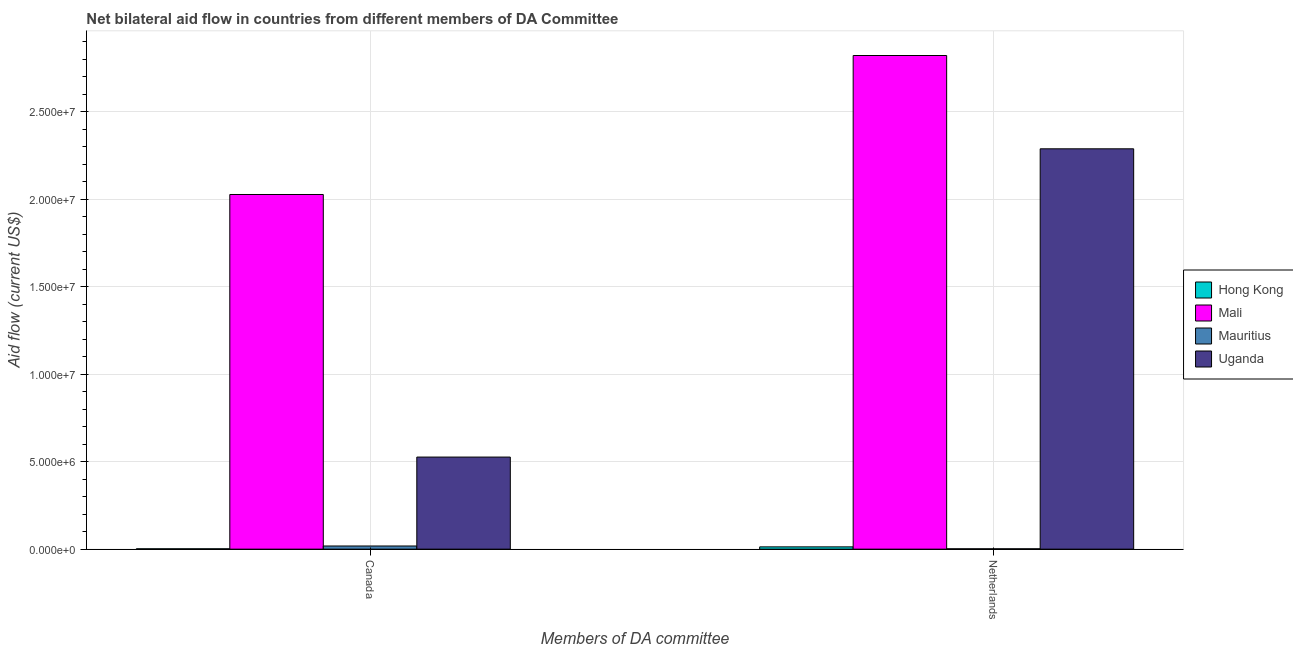Are the number of bars per tick equal to the number of legend labels?
Keep it short and to the point. Yes. How many bars are there on the 1st tick from the left?
Your answer should be very brief. 4. How many bars are there on the 1st tick from the right?
Make the answer very short. 4. What is the label of the 1st group of bars from the left?
Give a very brief answer. Canada. What is the amount of aid given by canada in Mali?
Your answer should be very brief. 2.03e+07. Across all countries, what is the maximum amount of aid given by canada?
Your answer should be very brief. 2.03e+07. Across all countries, what is the minimum amount of aid given by canada?
Provide a succinct answer. 2.00e+04. In which country was the amount of aid given by netherlands maximum?
Offer a terse response. Mali. In which country was the amount of aid given by netherlands minimum?
Your answer should be very brief. Mauritius. What is the total amount of aid given by netherlands in the graph?
Your answer should be very brief. 5.12e+07. What is the difference between the amount of aid given by canada in Mali and that in Mauritius?
Provide a short and direct response. 2.01e+07. What is the difference between the amount of aid given by canada in Hong Kong and the amount of aid given by netherlands in Mauritius?
Make the answer very short. 0. What is the average amount of aid given by canada per country?
Offer a terse response. 6.43e+06. What is the difference between the amount of aid given by netherlands and amount of aid given by canada in Mauritius?
Offer a very short reply. -1.60e+05. In how many countries, is the amount of aid given by canada greater than 17000000 US$?
Offer a terse response. 1. What is the ratio of the amount of aid given by canada in Mauritius to that in Mali?
Your answer should be very brief. 0.01. Is the amount of aid given by netherlands in Mali less than that in Uganda?
Provide a succinct answer. No. In how many countries, is the amount of aid given by canada greater than the average amount of aid given by canada taken over all countries?
Keep it short and to the point. 1. What does the 3rd bar from the left in Canada represents?
Your response must be concise. Mauritius. What does the 2nd bar from the right in Canada represents?
Offer a terse response. Mauritius. Are all the bars in the graph horizontal?
Your response must be concise. No. How many countries are there in the graph?
Give a very brief answer. 4. What is the difference between two consecutive major ticks on the Y-axis?
Your response must be concise. 5.00e+06. Are the values on the major ticks of Y-axis written in scientific E-notation?
Your answer should be compact. Yes. Does the graph contain any zero values?
Give a very brief answer. No. Where does the legend appear in the graph?
Provide a succinct answer. Center right. How many legend labels are there?
Make the answer very short. 4. How are the legend labels stacked?
Provide a short and direct response. Vertical. What is the title of the graph?
Keep it short and to the point. Net bilateral aid flow in countries from different members of DA Committee. What is the label or title of the X-axis?
Your response must be concise. Members of DA committee. What is the Aid flow (current US$) of Hong Kong in Canada?
Offer a very short reply. 2.00e+04. What is the Aid flow (current US$) of Mali in Canada?
Keep it short and to the point. 2.03e+07. What is the Aid flow (current US$) of Uganda in Canada?
Make the answer very short. 5.26e+06. What is the Aid flow (current US$) of Hong Kong in Netherlands?
Offer a very short reply. 1.30e+05. What is the Aid flow (current US$) in Mali in Netherlands?
Ensure brevity in your answer.  2.82e+07. What is the Aid flow (current US$) of Mauritius in Netherlands?
Give a very brief answer. 2.00e+04. What is the Aid flow (current US$) in Uganda in Netherlands?
Your answer should be very brief. 2.29e+07. Across all Members of DA committee, what is the maximum Aid flow (current US$) of Mali?
Provide a succinct answer. 2.82e+07. Across all Members of DA committee, what is the maximum Aid flow (current US$) of Mauritius?
Offer a terse response. 1.80e+05. Across all Members of DA committee, what is the maximum Aid flow (current US$) of Uganda?
Provide a short and direct response. 2.29e+07. Across all Members of DA committee, what is the minimum Aid flow (current US$) in Hong Kong?
Offer a very short reply. 2.00e+04. Across all Members of DA committee, what is the minimum Aid flow (current US$) of Mali?
Offer a terse response. 2.03e+07. Across all Members of DA committee, what is the minimum Aid flow (current US$) of Uganda?
Provide a short and direct response. 5.26e+06. What is the total Aid flow (current US$) of Mali in the graph?
Provide a succinct answer. 4.85e+07. What is the total Aid flow (current US$) of Uganda in the graph?
Provide a succinct answer. 2.81e+07. What is the difference between the Aid flow (current US$) in Mali in Canada and that in Netherlands?
Offer a terse response. -7.94e+06. What is the difference between the Aid flow (current US$) of Mauritius in Canada and that in Netherlands?
Make the answer very short. 1.60e+05. What is the difference between the Aid flow (current US$) of Uganda in Canada and that in Netherlands?
Make the answer very short. -1.76e+07. What is the difference between the Aid flow (current US$) of Hong Kong in Canada and the Aid flow (current US$) of Mali in Netherlands?
Offer a terse response. -2.82e+07. What is the difference between the Aid flow (current US$) of Hong Kong in Canada and the Aid flow (current US$) of Mauritius in Netherlands?
Ensure brevity in your answer.  0. What is the difference between the Aid flow (current US$) of Hong Kong in Canada and the Aid flow (current US$) of Uganda in Netherlands?
Give a very brief answer. -2.28e+07. What is the difference between the Aid flow (current US$) of Mali in Canada and the Aid flow (current US$) of Mauritius in Netherlands?
Make the answer very short. 2.02e+07. What is the difference between the Aid flow (current US$) of Mali in Canada and the Aid flow (current US$) of Uganda in Netherlands?
Provide a succinct answer. -2.61e+06. What is the difference between the Aid flow (current US$) of Mauritius in Canada and the Aid flow (current US$) of Uganda in Netherlands?
Provide a short and direct response. -2.27e+07. What is the average Aid flow (current US$) of Hong Kong per Members of DA committee?
Your answer should be very brief. 7.50e+04. What is the average Aid flow (current US$) in Mali per Members of DA committee?
Provide a succinct answer. 2.42e+07. What is the average Aid flow (current US$) of Mauritius per Members of DA committee?
Make the answer very short. 1.00e+05. What is the average Aid flow (current US$) in Uganda per Members of DA committee?
Ensure brevity in your answer.  1.41e+07. What is the difference between the Aid flow (current US$) of Hong Kong and Aid flow (current US$) of Mali in Canada?
Offer a very short reply. -2.02e+07. What is the difference between the Aid flow (current US$) in Hong Kong and Aid flow (current US$) in Mauritius in Canada?
Offer a terse response. -1.60e+05. What is the difference between the Aid flow (current US$) in Hong Kong and Aid flow (current US$) in Uganda in Canada?
Your answer should be very brief. -5.24e+06. What is the difference between the Aid flow (current US$) in Mali and Aid flow (current US$) in Mauritius in Canada?
Offer a terse response. 2.01e+07. What is the difference between the Aid flow (current US$) of Mali and Aid flow (current US$) of Uganda in Canada?
Your answer should be compact. 1.50e+07. What is the difference between the Aid flow (current US$) in Mauritius and Aid flow (current US$) in Uganda in Canada?
Provide a succinct answer. -5.08e+06. What is the difference between the Aid flow (current US$) in Hong Kong and Aid flow (current US$) in Mali in Netherlands?
Make the answer very short. -2.81e+07. What is the difference between the Aid flow (current US$) in Hong Kong and Aid flow (current US$) in Mauritius in Netherlands?
Your answer should be very brief. 1.10e+05. What is the difference between the Aid flow (current US$) in Hong Kong and Aid flow (current US$) in Uganda in Netherlands?
Your answer should be very brief. -2.27e+07. What is the difference between the Aid flow (current US$) in Mali and Aid flow (current US$) in Mauritius in Netherlands?
Your response must be concise. 2.82e+07. What is the difference between the Aid flow (current US$) of Mali and Aid flow (current US$) of Uganda in Netherlands?
Keep it short and to the point. 5.33e+06. What is the difference between the Aid flow (current US$) of Mauritius and Aid flow (current US$) of Uganda in Netherlands?
Provide a short and direct response. -2.28e+07. What is the ratio of the Aid flow (current US$) of Hong Kong in Canada to that in Netherlands?
Keep it short and to the point. 0.15. What is the ratio of the Aid flow (current US$) of Mali in Canada to that in Netherlands?
Offer a very short reply. 0.72. What is the ratio of the Aid flow (current US$) of Mauritius in Canada to that in Netherlands?
Your response must be concise. 9. What is the ratio of the Aid flow (current US$) of Uganda in Canada to that in Netherlands?
Provide a short and direct response. 0.23. What is the difference between the highest and the second highest Aid flow (current US$) in Hong Kong?
Make the answer very short. 1.10e+05. What is the difference between the highest and the second highest Aid flow (current US$) of Mali?
Your response must be concise. 7.94e+06. What is the difference between the highest and the second highest Aid flow (current US$) of Mauritius?
Give a very brief answer. 1.60e+05. What is the difference between the highest and the second highest Aid flow (current US$) of Uganda?
Ensure brevity in your answer.  1.76e+07. What is the difference between the highest and the lowest Aid flow (current US$) of Mali?
Offer a terse response. 7.94e+06. What is the difference between the highest and the lowest Aid flow (current US$) of Mauritius?
Offer a terse response. 1.60e+05. What is the difference between the highest and the lowest Aid flow (current US$) in Uganda?
Your response must be concise. 1.76e+07. 